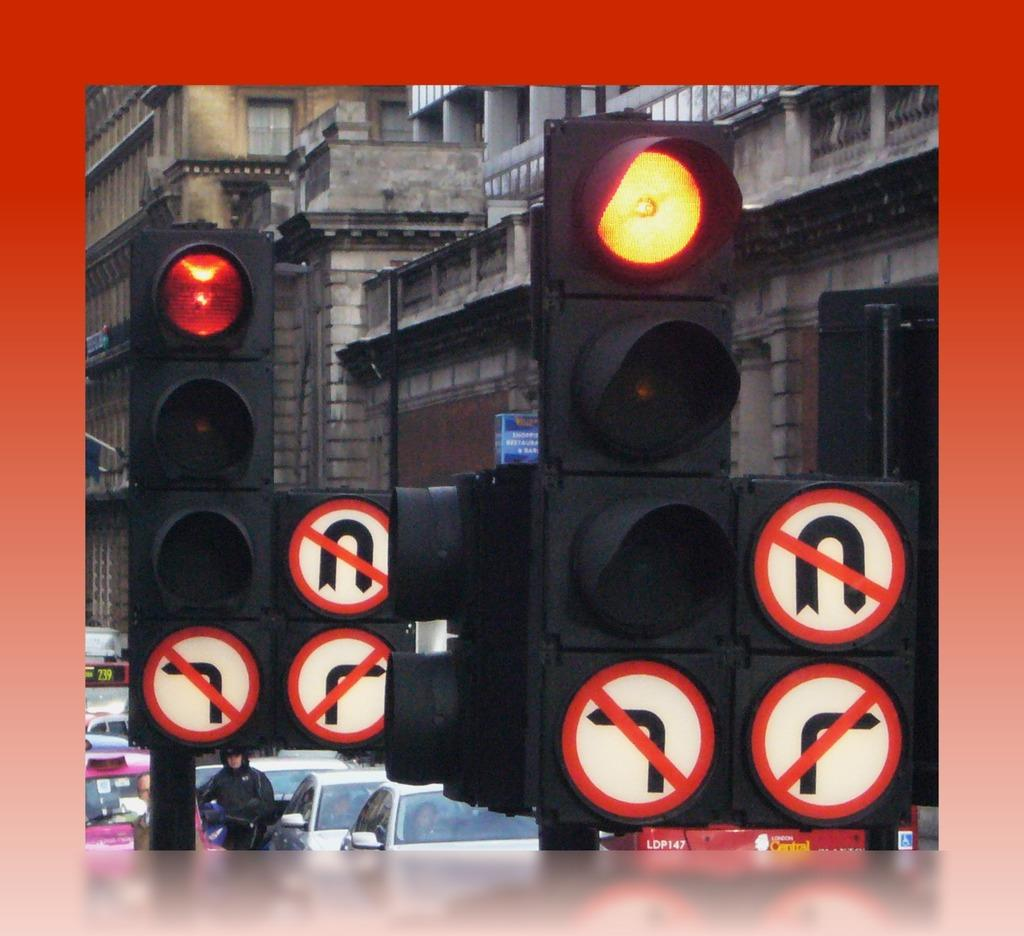What type of vehicles are at the bottom of the image? There are cars at the bottom of the image. What can be seen in the middle of the image? There are traffic signals in the middle of the image. What type of structures are visible in the background of the image? There are buildings in the background of the image. What type of yarn is being used to create the border in the image? There is no yarn or border present in the image. What type of insurance is being offered at the traffic signals in the image? There is no mention of insurance in the image; it features cars, traffic signals, and buildings. 